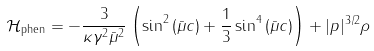<formula> <loc_0><loc_0><loc_500><loc_500>\mathcal { H } _ { \text {phen} } = - \frac { 3 } { \kappa \gamma ^ { 2 } \bar { \mu } ^ { 2 } } \left ( \sin ^ { 2 } { ( \bar { \mu } c ) } + \frac { 1 } { 3 } \sin ^ { 4 } { ( \bar { \mu } c ) } \right ) + | p | ^ { 3 / 2 } \rho</formula> 